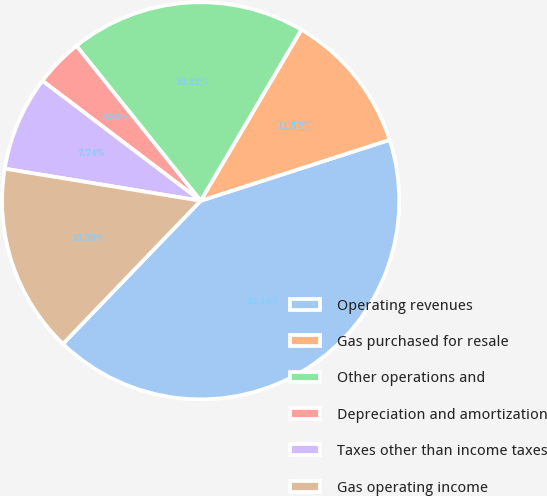<chart> <loc_0><loc_0><loc_500><loc_500><pie_chart><fcel>Operating revenues<fcel>Gas purchased for resale<fcel>Other operations and<fcel>Depreciation and amortization<fcel>Taxes other than income taxes<fcel>Gas operating income<nl><fcel>42.16%<fcel>11.57%<fcel>19.22%<fcel>3.92%<fcel>7.74%<fcel>15.39%<nl></chart> 